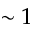Convert formula to latex. <formula><loc_0><loc_0><loc_500><loc_500>\sim 1</formula> 